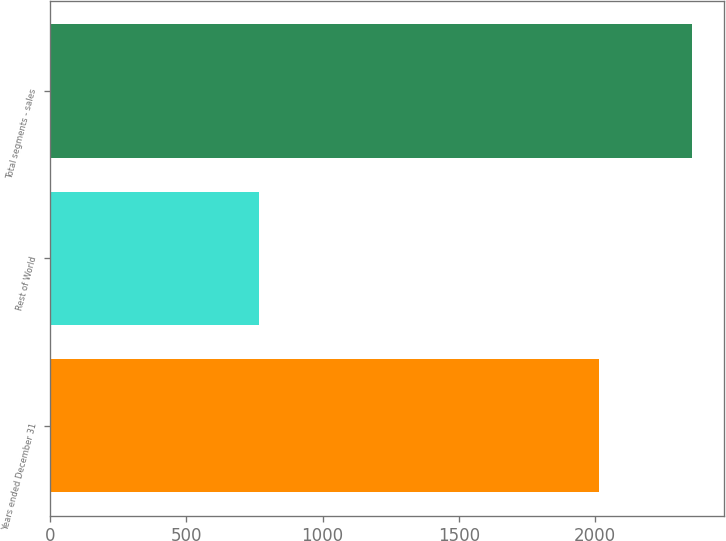<chart> <loc_0><loc_0><loc_500><loc_500><bar_chart><fcel>Years ended December 31<fcel>Rest of World<fcel>Total segments - sales<nl><fcel>2014<fcel>768.3<fcel>2356<nl></chart> 